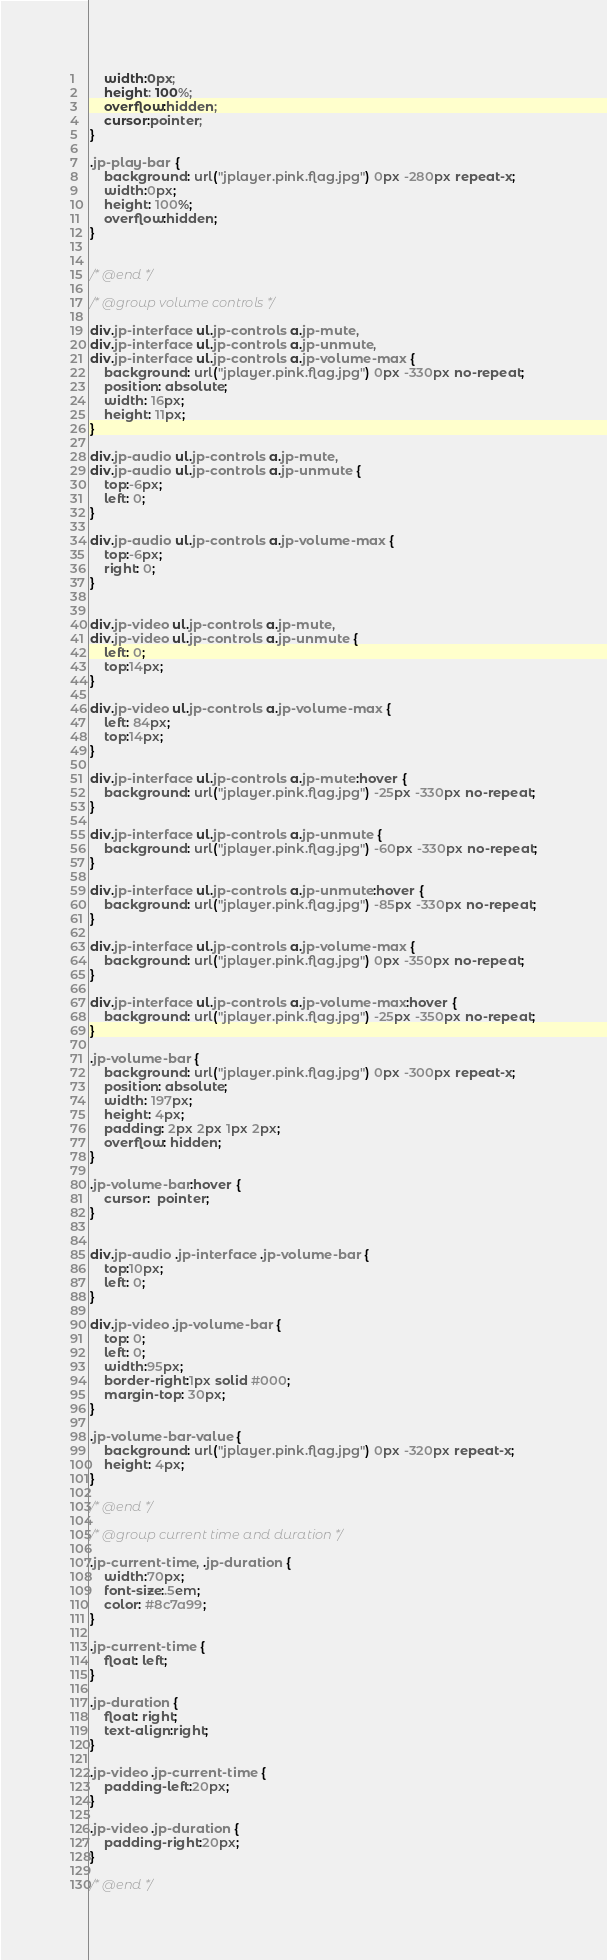<code> <loc_0><loc_0><loc_500><loc_500><_CSS_>	width:0px;
	height: 100%;
	overflow:hidden;
	cursor:pointer;
}

.jp-play-bar {
	background: url("jplayer.pink.flag.jpg") 0px -280px repeat-x;
	width:0px;
	height: 100%;
	overflow:hidden;
}


/* @end */

/* @group volume controls */

div.jp-interface ul.jp-controls a.jp-mute,
div.jp-interface ul.jp-controls a.jp-unmute,
div.jp-interface ul.jp-controls a.jp-volume-max {
	background: url("jplayer.pink.flag.jpg") 0px -330px no-repeat;
	position: absolute;
	width: 16px;
	height: 11px;
}

div.jp-audio ul.jp-controls a.jp-mute,
div.jp-audio ul.jp-controls a.jp-unmute {
	top:-6px;
	left: 0;
}

div.jp-audio ul.jp-controls a.jp-volume-max {
	top:-6px;
	right: 0;
}


div.jp-video ul.jp-controls a.jp-mute,
div.jp-video ul.jp-controls a.jp-unmute {
	left: 0;
	top:14px;
}

div.jp-video ul.jp-controls a.jp-volume-max {
	left: 84px;
	top:14px;
}

div.jp-interface ul.jp-controls a.jp-mute:hover {
	background: url("jplayer.pink.flag.jpg") -25px -330px no-repeat;
}

div.jp-interface ul.jp-controls a.jp-unmute {
	background: url("jplayer.pink.flag.jpg") -60px -330px no-repeat;
}

div.jp-interface ul.jp-controls a.jp-unmute:hover {
	background: url("jplayer.pink.flag.jpg") -85px -330px no-repeat;
}

div.jp-interface ul.jp-controls a.jp-volume-max {
	background: url("jplayer.pink.flag.jpg") 0px -350px no-repeat;
}

div.jp-interface ul.jp-controls a.jp-volume-max:hover {
	background: url("jplayer.pink.flag.jpg") -25px -350px no-repeat;
}

.jp-volume-bar {
	background: url("jplayer.pink.flag.jpg") 0px -300px repeat-x;
	position: absolute;
	width: 197px;
	height: 4px;
	padding: 2px 2px 1px 2px;
	overflow: hidden;
}

.jp-volume-bar:hover {
	cursor:  pointer;
}


div.jp-audio .jp-interface .jp-volume-bar {
	top:10px;
	left: 0;
}

div.jp-video .jp-volume-bar {
	top: 0;
	left: 0;
	width:95px;
	border-right:1px solid #000;
	margin-top: 30px;
}

.jp-volume-bar-value {
	background: url("jplayer.pink.flag.jpg") 0px -320px repeat-x;
	height: 4px;
}

/* @end */

/* @group current time and duration */

.jp-current-time, .jp-duration {
	width:70px;
	font-size:.5em;
	color: #8c7a99;
}

.jp-current-time {
	float: left;
}

.jp-duration {
	float: right;
	text-align:right;
}

.jp-video .jp-current-time {
	padding-left:20px;
}

.jp-video .jp-duration {
	padding-right:20px;
}

/* @end */
</code> 